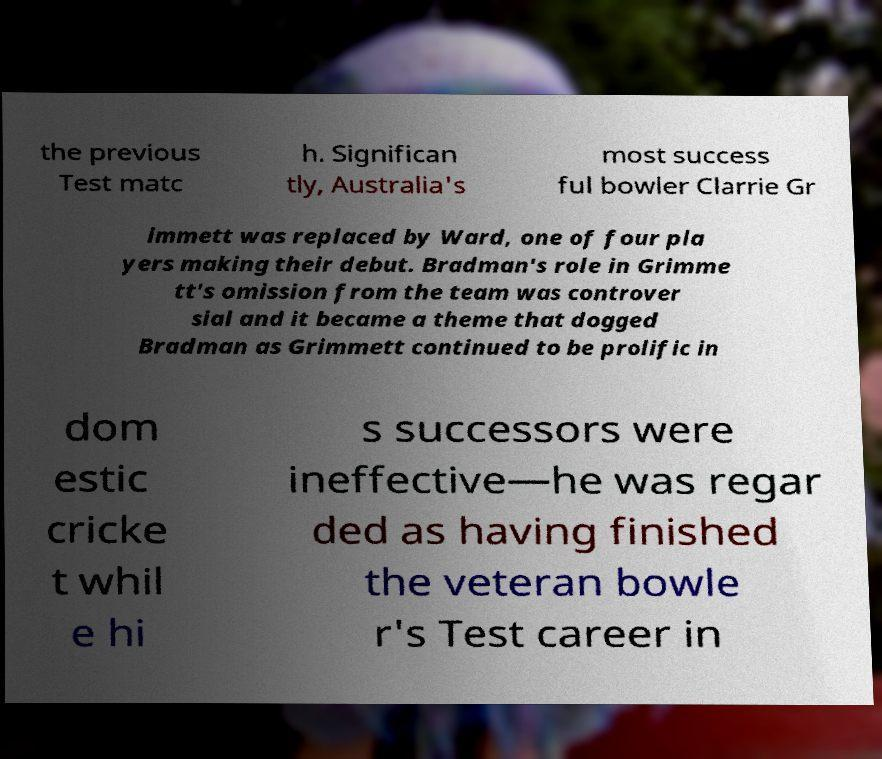What messages or text are displayed in this image? I need them in a readable, typed format. the previous Test matc h. Significan tly, Australia's most success ful bowler Clarrie Gr immett was replaced by Ward, one of four pla yers making their debut. Bradman's role in Grimme tt's omission from the team was controver sial and it became a theme that dogged Bradman as Grimmett continued to be prolific in dom estic cricke t whil e hi s successors were ineffective—he was regar ded as having finished the veteran bowle r's Test career in 